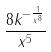Convert formula to latex. <formula><loc_0><loc_0><loc_500><loc_500>\frac { 8 k ^ { - \frac { 1 } { x ^ { 8 } } } } { x ^ { 5 } }</formula> 